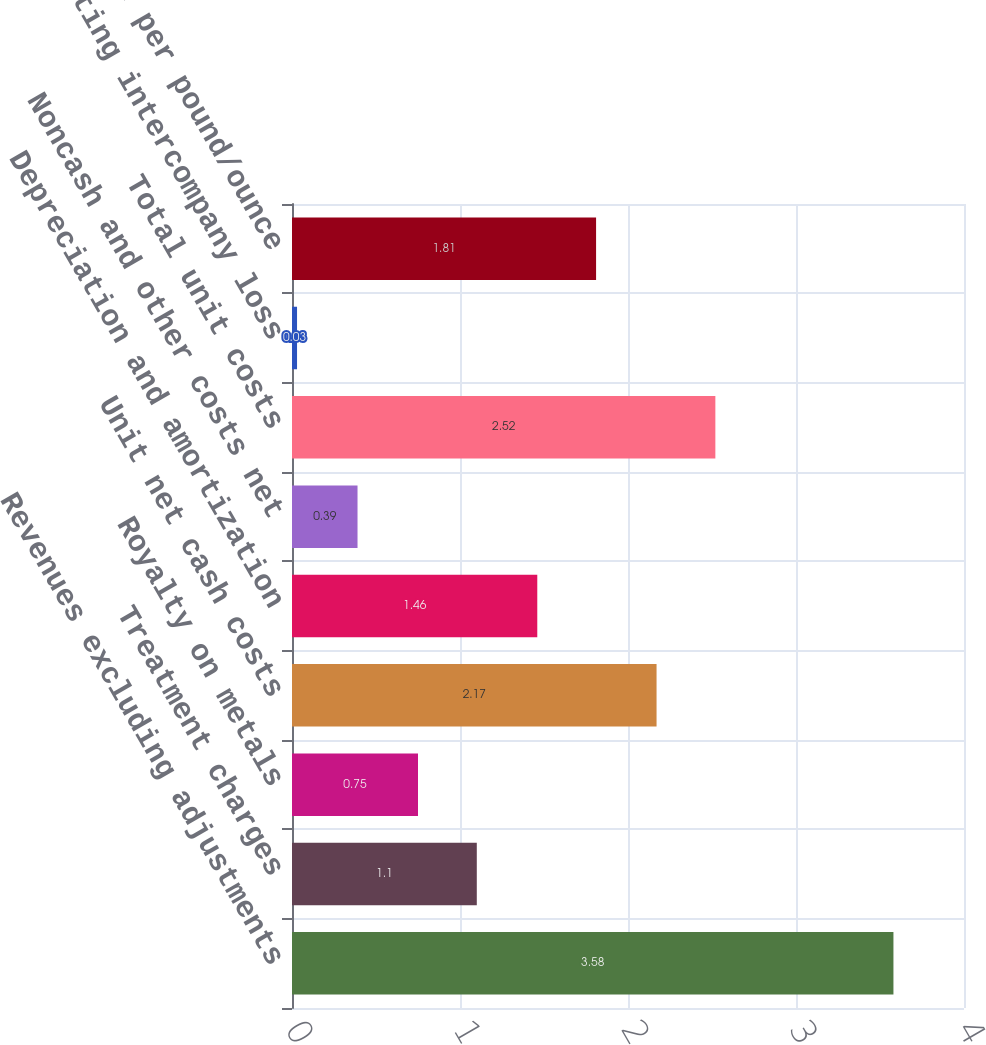Convert chart to OTSL. <chart><loc_0><loc_0><loc_500><loc_500><bar_chart><fcel>Revenues excluding adjustments<fcel>Treatment charges<fcel>Royalty on metals<fcel>Unit net cash costs<fcel>Depreciation and amortization<fcel>Noncash and other costs net<fcel>Total unit costs<fcel>PT Smelting intercompany loss<fcel>Gross profit per pound/ounce<nl><fcel>3.58<fcel>1.1<fcel>0.75<fcel>2.17<fcel>1.46<fcel>0.39<fcel>2.52<fcel>0.03<fcel>1.81<nl></chart> 